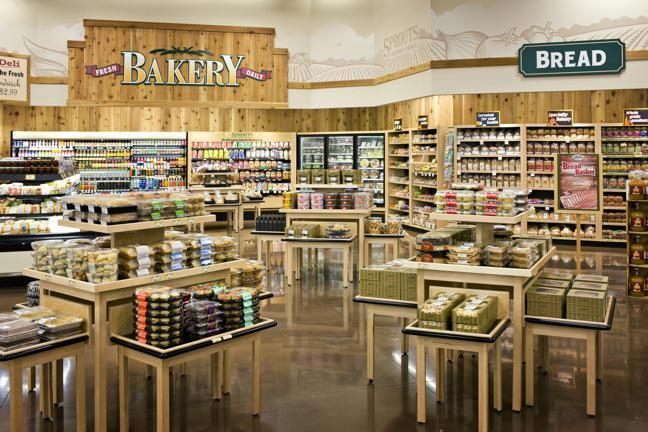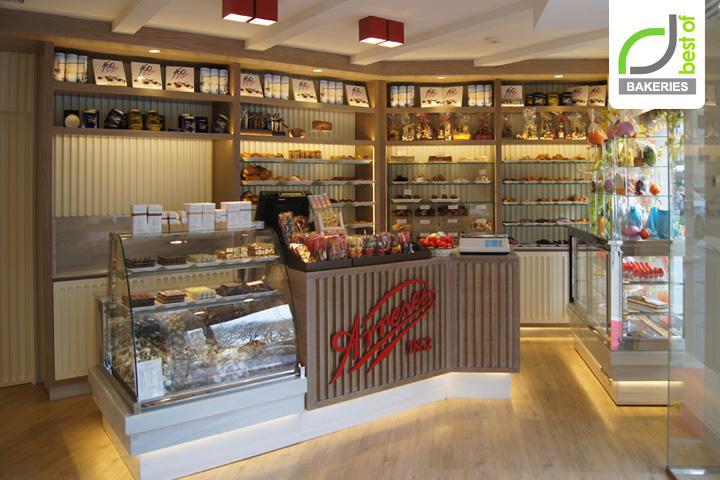The first image is the image on the left, the second image is the image on the right. Given the left and right images, does the statement "the bakery sign is on the wall" hold true? Answer yes or no. Yes. The first image is the image on the left, the second image is the image on the right. Analyze the images presented: Is the assertion "Bread that is not in any individual packaging is displayed for sale." valid? Answer yes or no. No. 